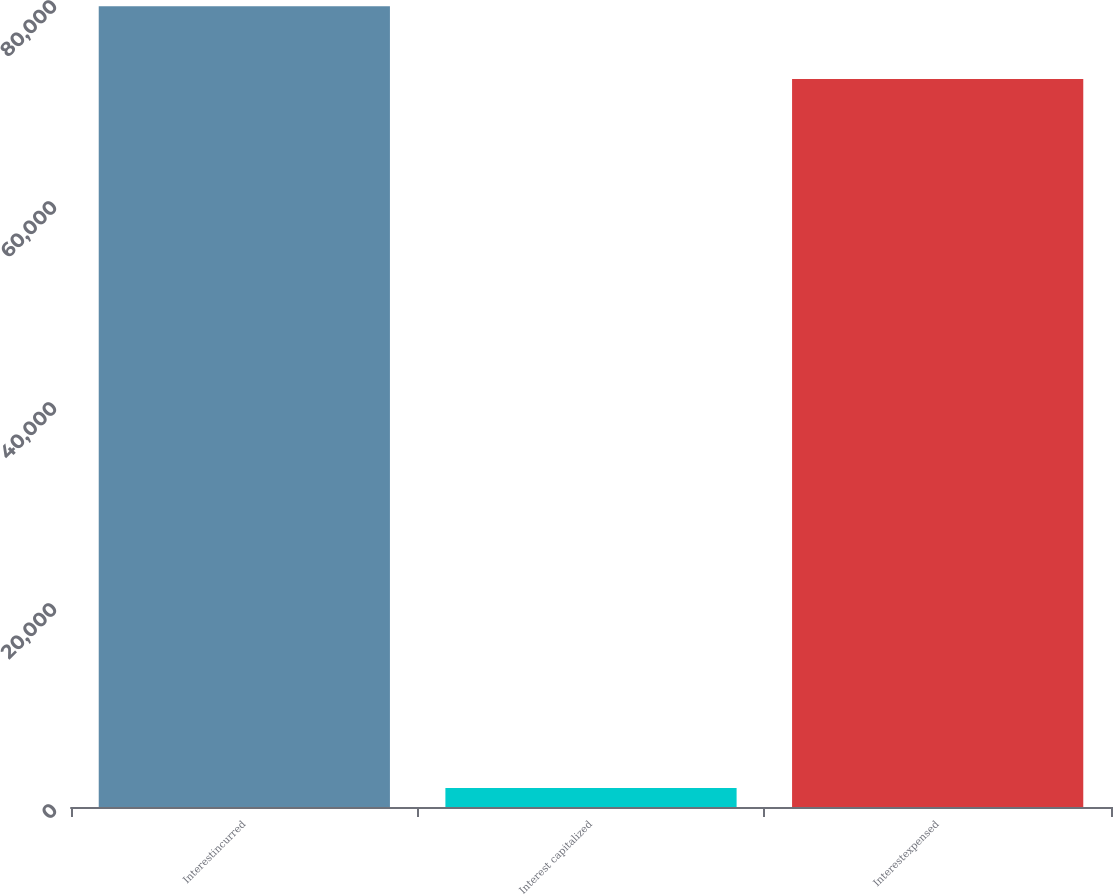Convert chart to OTSL. <chart><loc_0><loc_0><loc_500><loc_500><bar_chart><fcel>Interestincurred<fcel>Interest capitalized<fcel>Interestexpensed<nl><fcel>79685.1<fcel>1900<fcel>72441<nl></chart> 